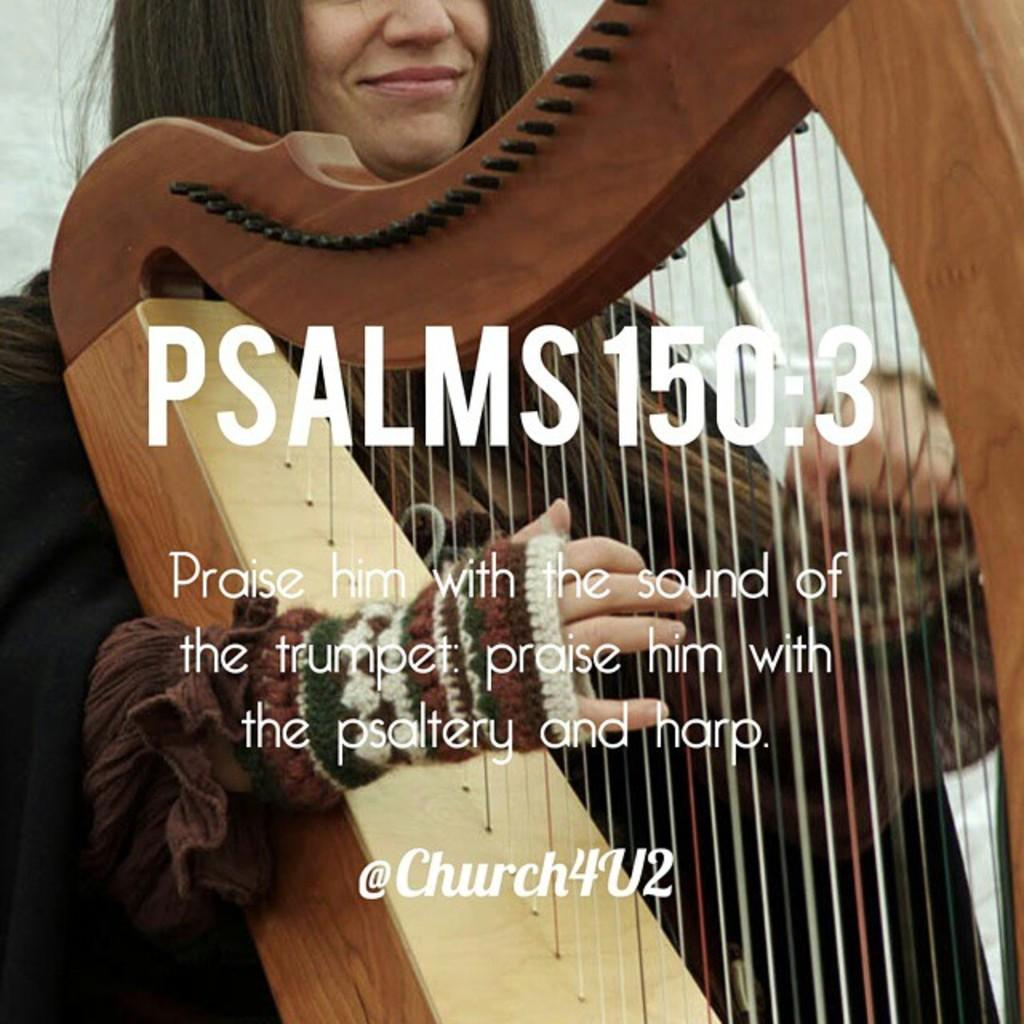What is the woman in the image doing? The woman is playing an instrument in the image. Can you describe the woman's appearance? The woman has black hair. What is the instrument made of? The instrument is made of wood. Can you see a man riding a wave in the image? No, there is no man riding a wave in the image. What type of bit is the woman using to play the instrument? There is no bit present in the image, as the instrument is made of wood and does not require a bit for playing. 